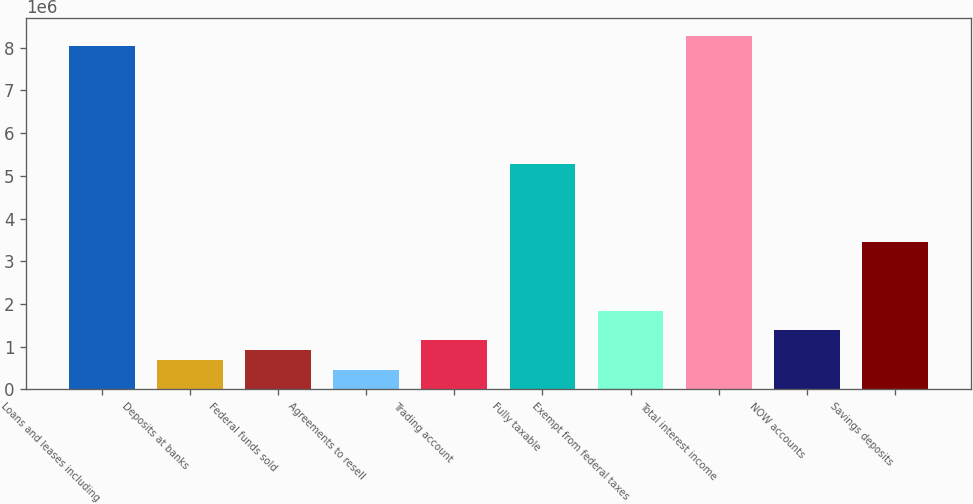Convert chart to OTSL. <chart><loc_0><loc_0><loc_500><loc_500><bar_chart><fcel>Loans and leases including<fcel>Deposits at banks<fcel>Federal funds sold<fcel>Agreements to resell<fcel>Trading account<fcel>Fully taxable<fcel>Exempt from federal taxes<fcel>Total interest income<fcel>NOW accounts<fcel>Savings deposits<nl><fcel>8.04555e+06<fcel>689624<fcel>919496<fcel>459751<fcel>1.14937e+06<fcel>5.28708e+06<fcel>1.83899e+06<fcel>8.27542e+06<fcel>1.37924e+06<fcel>3.4481e+06<nl></chart> 